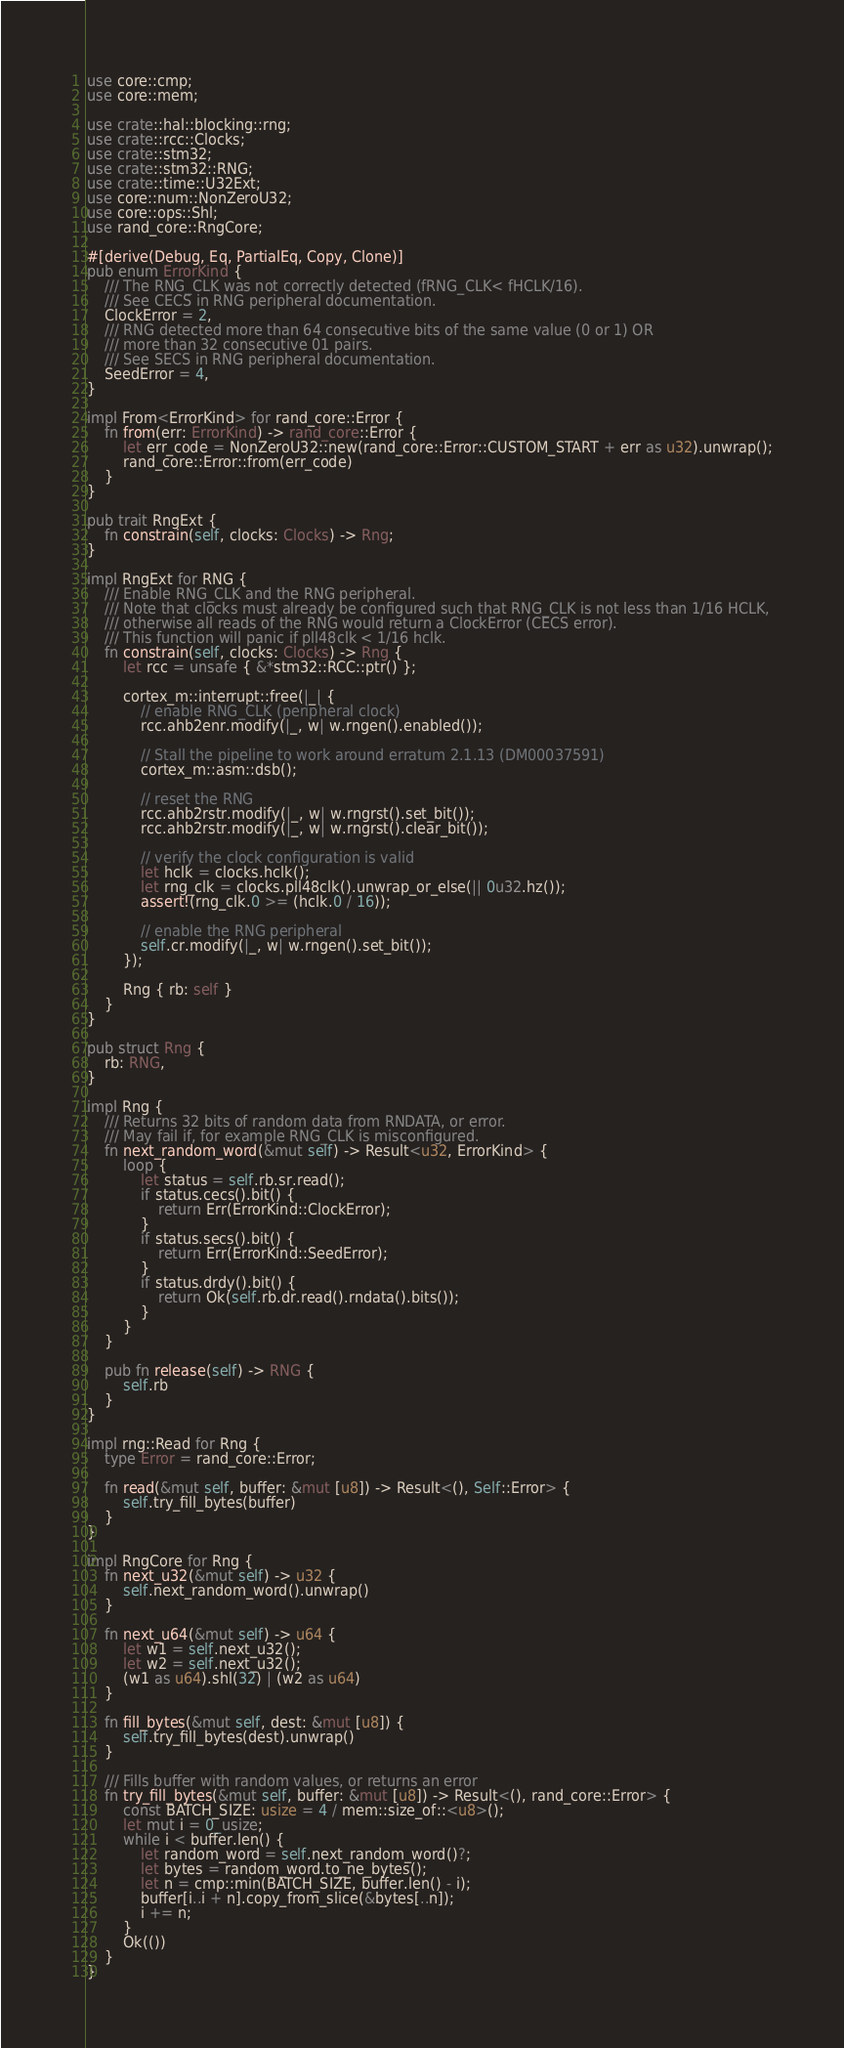<code> <loc_0><loc_0><loc_500><loc_500><_Rust_>use core::cmp;
use core::mem;

use crate::hal::blocking::rng;
use crate::rcc::Clocks;
use crate::stm32;
use crate::stm32::RNG;
use crate::time::U32Ext;
use core::num::NonZeroU32;
use core::ops::Shl;
use rand_core::RngCore;

#[derive(Debug, Eq, PartialEq, Copy, Clone)]
pub enum ErrorKind {
    /// The RNG_CLK was not correctly detected (fRNG_CLK< fHCLK/16).
    /// See CECS in RNG peripheral documentation.
    ClockError = 2,
    /// RNG detected more than 64 consecutive bits of the same value (0 or 1) OR
    /// more than 32 consecutive 01 pairs.
    /// See SECS in RNG peripheral documentation.
    SeedError = 4,
}

impl From<ErrorKind> for rand_core::Error {
    fn from(err: ErrorKind) -> rand_core::Error {
        let err_code = NonZeroU32::new(rand_core::Error::CUSTOM_START + err as u32).unwrap();
        rand_core::Error::from(err_code)
    }
}

pub trait RngExt {
    fn constrain(self, clocks: Clocks) -> Rng;
}

impl RngExt for RNG {
    /// Enable RNG_CLK and the RNG peripheral.
    /// Note that clocks must already be configured such that RNG_CLK is not less than 1/16 HCLK,
    /// otherwise all reads of the RNG would return a ClockError (CECS error).
    /// This function will panic if pll48clk < 1/16 hclk.
    fn constrain(self, clocks: Clocks) -> Rng {
        let rcc = unsafe { &*stm32::RCC::ptr() };

        cortex_m::interrupt::free(|_| {
            // enable RNG_CLK (peripheral clock)
            rcc.ahb2enr.modify(|_, w| w.rngen().enabled());

            // Stall the pipeline to work around erratum 2.1.13 (DM00037591)
            cortex_m::asm::dsb();

            // reset the RNG
            rcc.ahb2rstr.modify(|_, w| w.rngrst().set_bit());
            rcc.ahb2rstr.modify(|_, w| w.rngrst().clear_bit());

            // verify the clock configuration is valid
            let hclk = clocks.hclk();
            let rng_clk = clocks.pll48clk().unwrap_or_else(|| 0u32.hz());
            assert!(rng_clk.0 >= (hclk.0 / 16));

            // enable the RNG peripheral
            self.cr.modify(|_, w| w.rngen().set_bit());
        });

        Rng { rb: self }
    }
}

pub struct Rng {
    rb: RNG,
}

impl Rng {
    /// Returns 32 bits of random data from RNDATA, or error.
    /// May fail if, for example RNG_CLK is misconfigured.
    fn next_random_word(&mut self) -> Result<u32, ErrorKind> {
        loop {
            let status = self.rb.sr.read();
            if status.cecs().bit() {
                return Err(ErrorKind::ClockError);
            }
            if status.secs().bit() {
                return Err(ErrorKind::SeedError);
            }
            if status.drdy().bit() {
                return Ok(self.rb.dr.read().rndata().bits());
            }
        }
    }

    pub fn release(self) -> RNG {
        self.rb
    }
}

impl rng::Read for Rng {
    type Error = rand_core::Error;

    fn read(&mut self, buffer: &mut [u8]) -> Result<(), Self::Error> {
        self.try_fill_bytes(buffer)
    }
}

impl RngCore for Rng {
    fn next_u32(&mut self) -> u32 {
        self.next_random_word().unwrap()
    }

    fn next_u64(&mut self) -> u64 {
        let w1 = self.next_u32();
        let w2 = self.next_u32();
        (w1 as u64).shl(32) | (w2 as u64)
    }

    fn fill_bytes(&mut self, dest: &mut [u8]) {
        self.try_fill_bytes(dest).unwrap()
    }

    /// Fills buffer with random values, or returns an error
    fn try_fill_bytes(&mut self, buffer: &mut [u8]) -> Result<(), rand_core::Error> {
        const BATCH_SIZE: usize = 4 / mem::size_of::<u8>();
        let mut i = 0_usize;
        while i < buffer.len() {
            let random_word = self.next_random_word()?;
            let bytes = random_word.to_ne_bytes();
            let n = cmp::min(BATCH_SIZE, buffer.len() - i);
            buffer[i..i + n].copy_from_slice(&bytes[..n]);
            i += n;
        }
        Ok(())
    }
}
</code> 